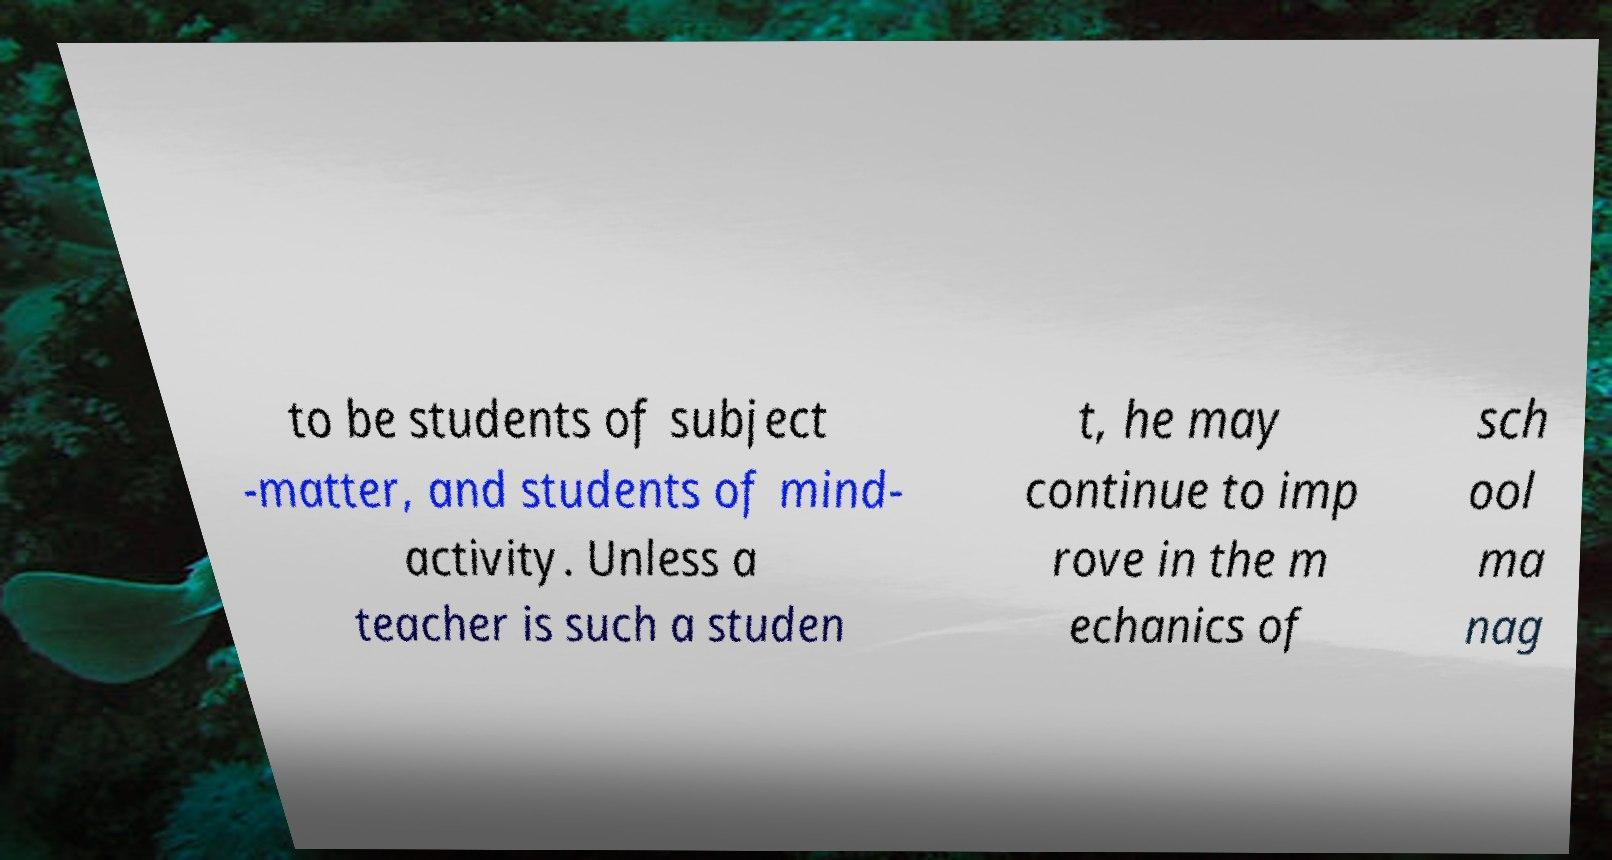Could you extract and type out the text from this image? to be students of subject -matter, and students of mind- activity. Unless a teacher is such a studen t, he may continue to imp rove in the m echanics of sch ool ma nag 